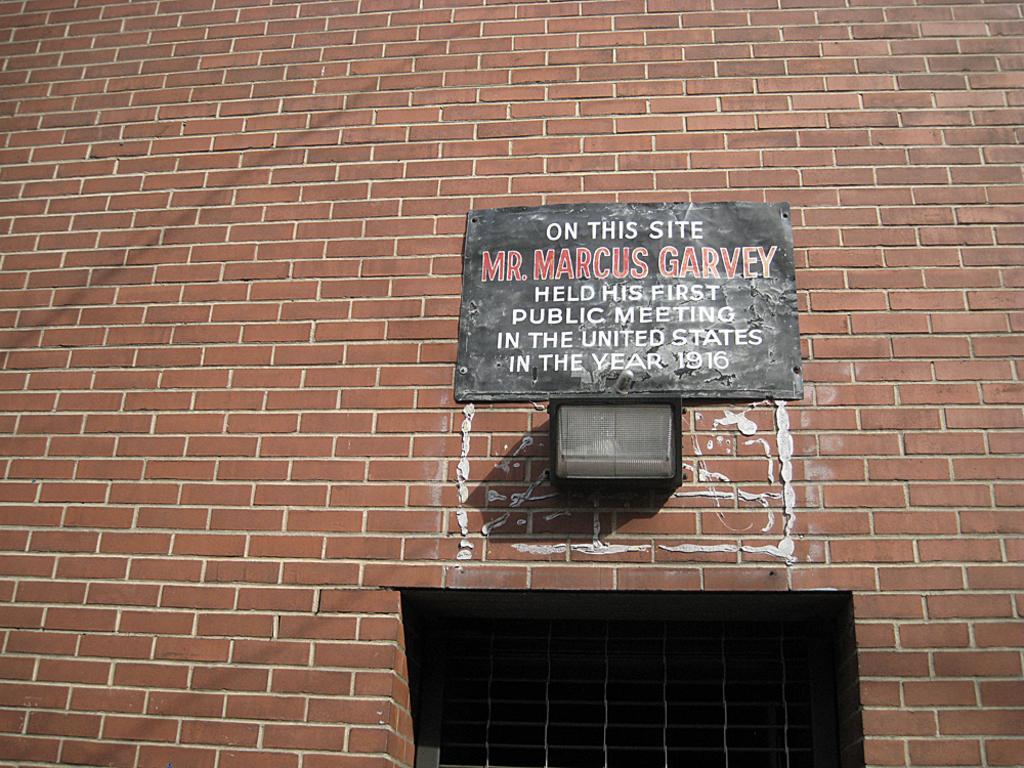What type of structure can be seen in the image? There is a wall in the image. What is attached to the wall? There is a board with text in the image. What can provide illumination in the image? There is a light in the image. What allows natural light to enter the space in the image? There is a window in the image. What type of amusement can be seen in the image? There is no amusement present in the image. 